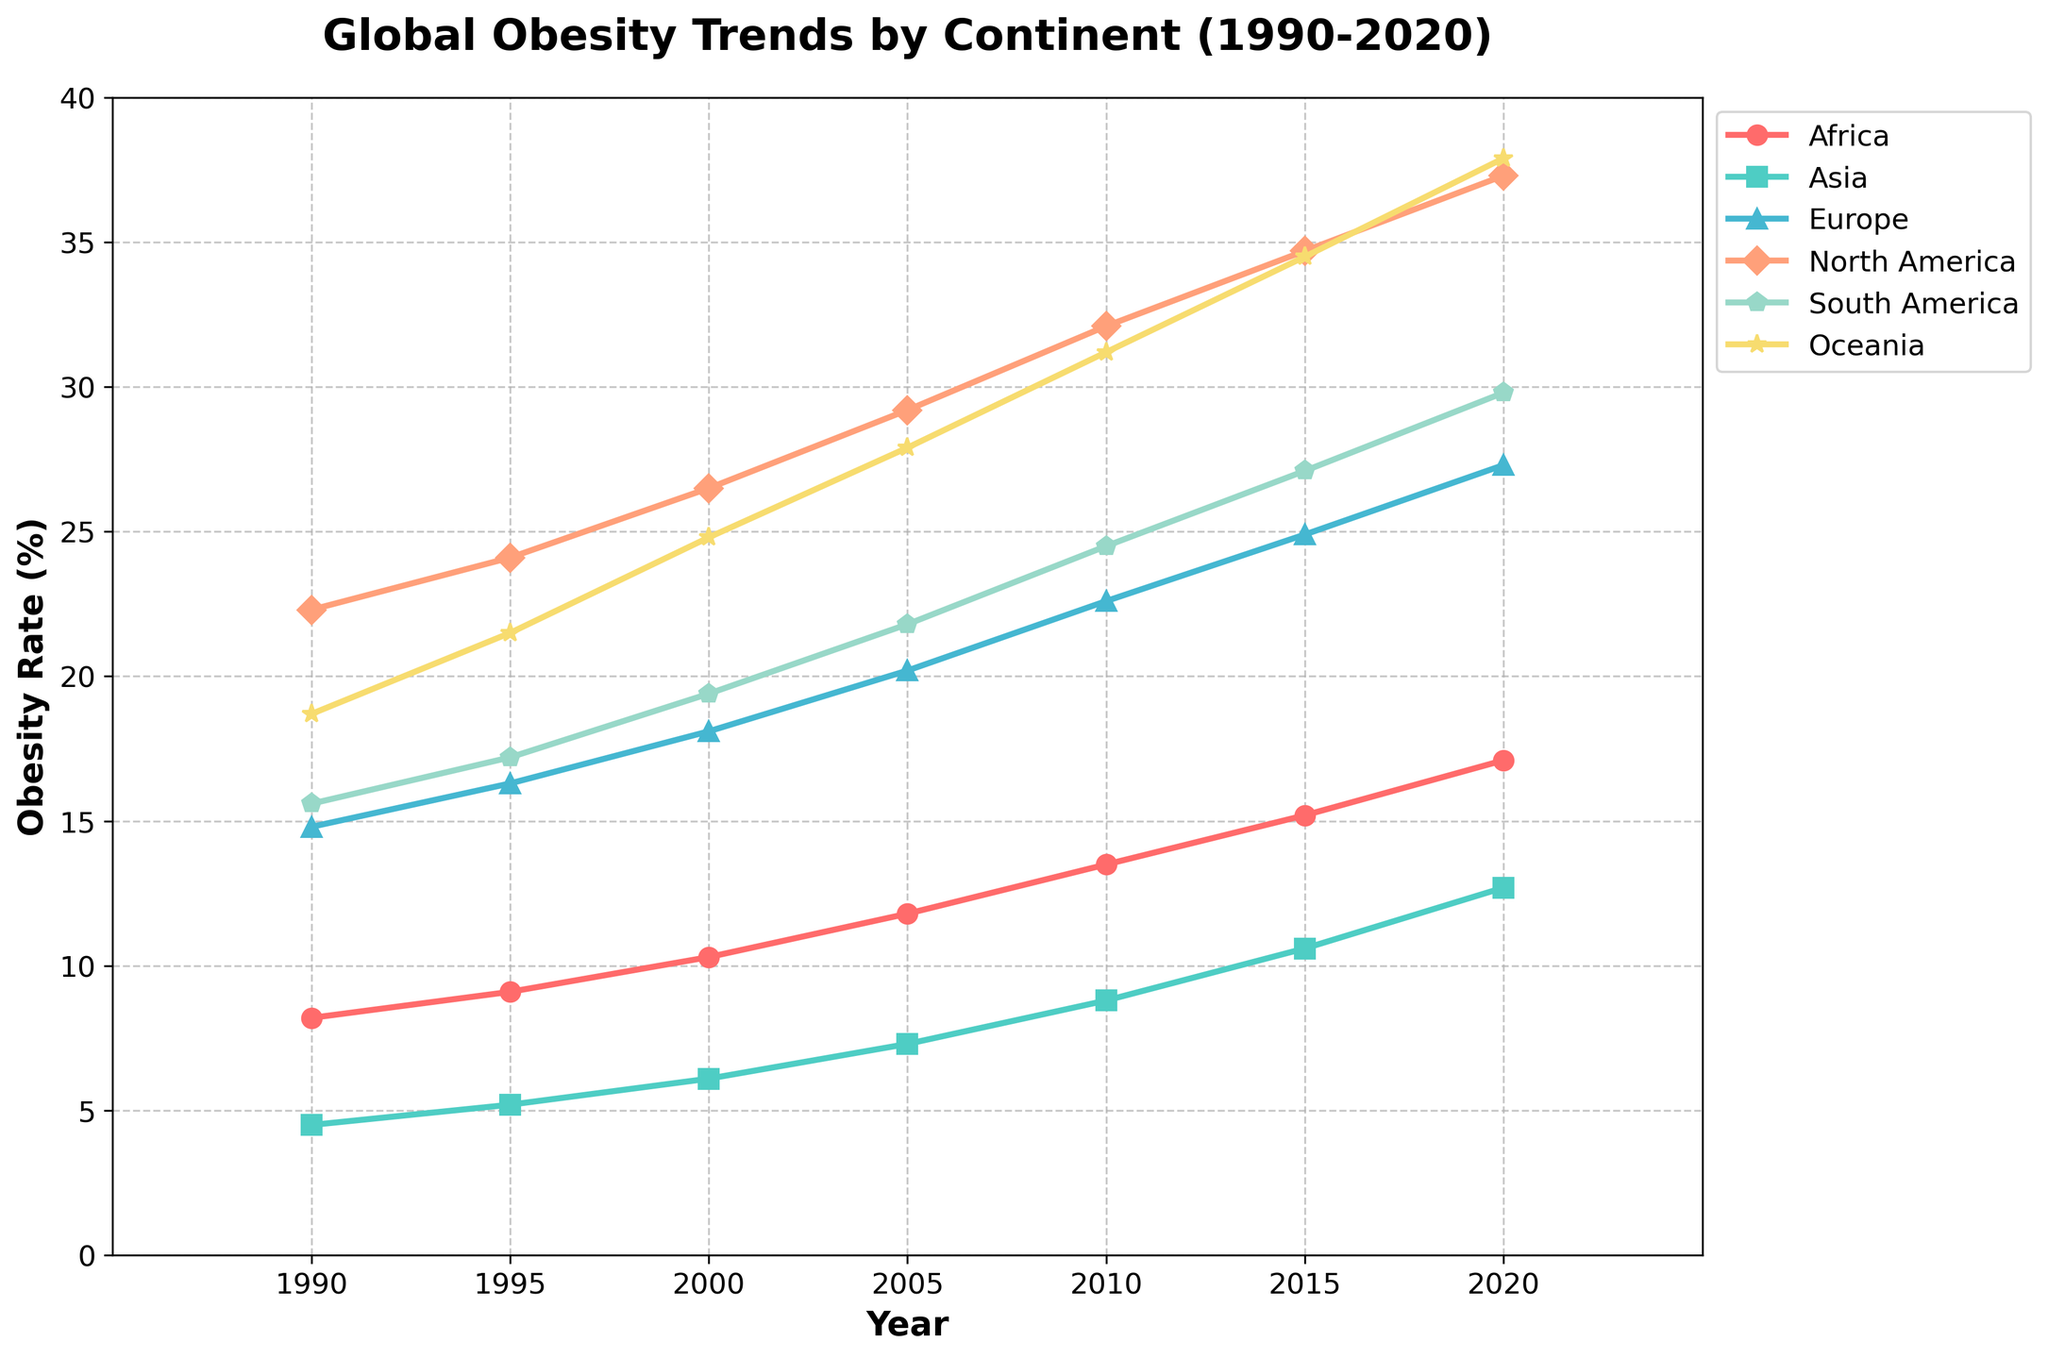What is the trend of obesity rates in North America from 1990 to 2020? The trend can be observed by looking at the line for North America. The obesity rate in North America increases steadily from 22.3% in 1990 to 37.3% in 2020, indicating a rising trend over the years.
Answer: Increasing Which continent had the lowest obesity rate in 2010? To determine the lowest obesity rate in 2010, compare the data points for each continent in that year. Asia had the lowest rate at 8.8%.
Answer: Asia By how many percentage points did the obesity rate in Africa increase from 1990 to 2020? The obesity rate in Africa in 1990 was 8.2%, and by 2020, it was 17.1%. The increase is calculated as 17.1% - 8.2% = 8.9%.
Answer: 8.9% Which continent shows the highest overall increase in obesity rate from 1990 to 2020? To identify the highest overall increase, subtract the 1990 rate from the 2020 rate for each continent and compare the values. North America shows the highest increase from 22.3% in 1990 to 37.3% in 2020, an increase of 15.0%.
Answer: North America In which year did Oceania surpass a 30% obesity rate? To find this, look at the line for Oceania and identify the first year where the obesity rate is greater than 30%. In 2010, Oceania's obesity rate was 31.2%, surpassing the 30% mark.
Answer: 2010 What is the average obesity rate in Europe for the years 1990, 2000, and 2010? The rates for Europe in the given years are 14.8% (1990), 18.1% (2000), and 22.6% (2010). Average is calculated as (14.8 + 18.1 + 22.6) / 3 = 18.5%.
Answer: 18.5% Which continent had the most rapid increase in obesity rate between 2000 and 2020? Calculate the difference in obesity rates between 2000 and 2020 for each continent and identify the highest. North America had the most rapid increase, from 26.5% to 37.3%, which is an increase of 10.8%.
Answer: North America In 2015, how many continents had an obesity rate above 20%? Review the 2015 data points and count the continents with rates above 20%. Africa (15.2), Asia (10.6), Europe (24.9), North America (34.7), South America (27.1), and Oceania (34.5). Europe, North America, South America, and Oceania had rates above 20%, totaling 4 continents.
Answer: 4 Compare the obesity rates of South America and Oceania in 2005. Which one was higher and by how much? For 2005, South America's rate was 21.8% and Oceania's was 27.9%. Oceania's rate was higher. The difference is found by 27.9% - 21.8% = 6.1%.
Answer: Oceania, 6.1% What color represents Asia in the line chart, and how can you tell? From the provided plot code, Asia is the second data series, with the color assigned being the second in the list [#4ECDC4]. The corresponding color for Asia is turquoise.
Answer: Turquoise 